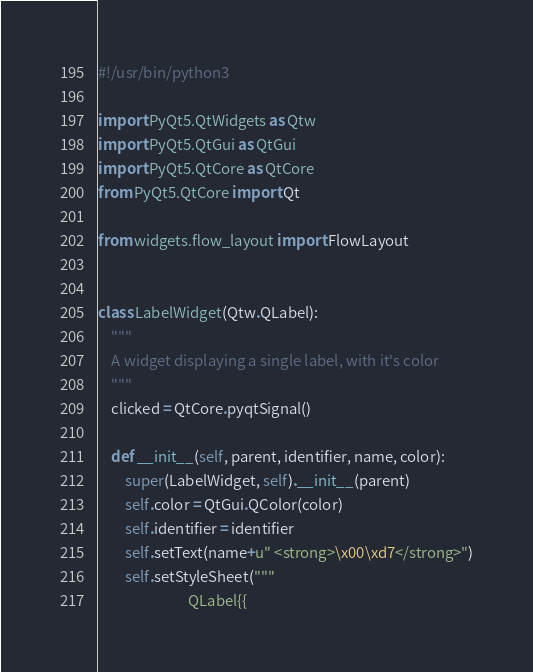<code> <loc_0><loc_0><loc_500><loc_500><_Python_>#!/usr/bin/python3

import PyQt5.QtWidgets as Qtw
import PyQt5.QtGui as QtGui
import PyQt5.QtCore as QtCore
from PyQt5.QtCore import Qt

from widgets.flow_layout import FlowLayout


class LabelWidget(Qtw.QLabel):
    """
    A widget displaying a single label, with it's color
    """
    clicked = QtCore.pyqtSignal()

    def __init__(self, parent, identifier, name, color):
        super(LabelWidget, self).__init__(parent)
        self.color = QtGui.QColor(color)
        self.identifier = identifier
        self.setText(name+u" <strong>\x00\xd7</strong>")
        self.setStyleSheet("""
                           QLabel{{</code> 